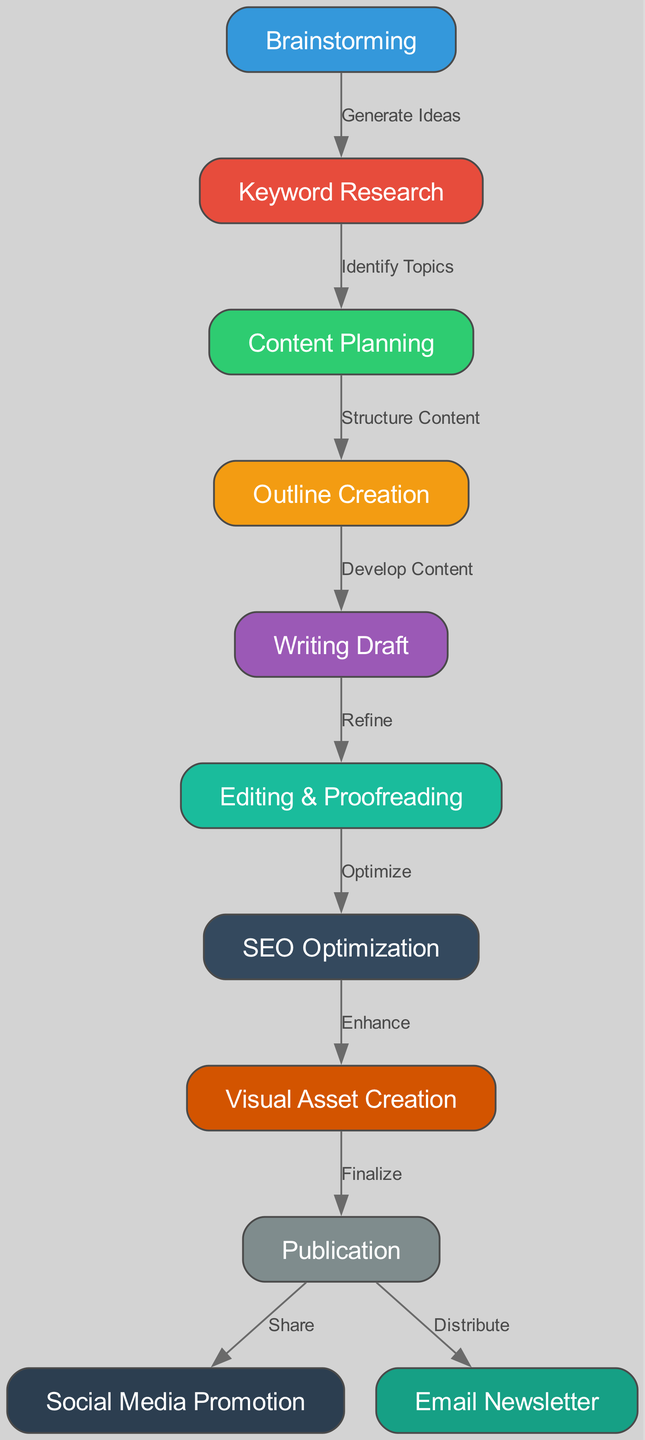What is the first step in the content creation process? The diagram clearly labels "Brainstorming" as the first node, indicating it is the initial step in the content creation process.
Answer: Brainstorming How many nodes are present in the diagram? Counting the nodes in the diagram shows 11 distinct steps in the content creation process.
Answer: 11 What comes after "Writing Draft"? The diagram shows an arrow from "Writing Draft" pointing to "Editing & Proofreading", indicating that this is the next step after drafting content.
Answer: Editing & Proofreading Which node is related to the creation of visual assets? The node "Visual Asset Creation" specifically mentions the creation of visuals, as indicated directly in its label within the diagram.
Answer: Visual Asset Creation How many different promotional channels are indicated after publication? The diagram illustrates two channels: "Social Media Promotion" and "Email Newsletter" leading from the "Publication" node, indicating multiple methods for promotion.
Answer: 2 What process comes before "SEO Optimization"? In the flow of the diagram, "Editing & Proofreading" directly leads into "SEO Optimization," marking it as the step that precedes optimization.
Answer: Editing & Proofreading Which two nodes indicate the stages of content enhancement and sharing? The diagram outlines "SEO Optimization" and "Visual Asset Creation" leading to "Publication", which signifies the enhancement process before sharing the content.
Answer: SEO Optimization and Visual Asset Creation What is the last step in the content creation process? Looking at the diagram, the final step reaching out from "Publication" is towards "Social Media Promotion" and "Email Newsletter", indicating these are the concluding actions taken.
Answer: Social Media Promotion and Email Newsletter What is the relationship between "Keyword Research" and "Content Planning"? The diagram presents a connection from "Keyword Research" to "Content Planning", indicating that keyword research is essential in planning the content.
Answer: Identify Topics 